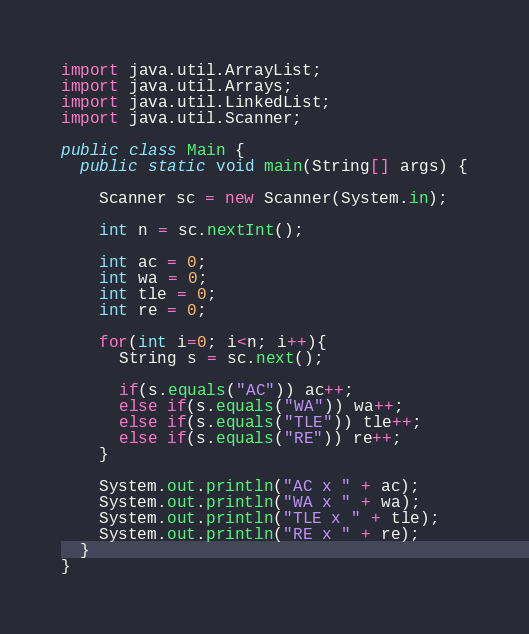Convert code to text. <code><loc_0><loc_0><loc_500><loc_500><_Java_>import java.util.ArrayList;
import java.util.Arrays;
import java.util.LinkedList;
import java.util.Scanner;

public class Main {
  public static void main(String[] args) {

    Scanner sc = new Scanner(System.in);
    
    int n = sc.nextInt();

    int ac = 0;
    int wa = 0;
    int tle = 0;
    int re = 0;
    
    for(int i=0; i<n; i++){
      String s = sc.next();

      if(s.equals("AC")) ac++;
      else if(s.equals("WA")) wa++;
      else if(s.equals("TLE")) tle++;
      else if(s.equals("RE")) re++;
    }

    System.out.println("AC x " + ac);
    System.out.println("WA x " + wa);
    System.out.println("TLE x " + tle);
    System.out.println("RE x " + re);
  }
}</code> 